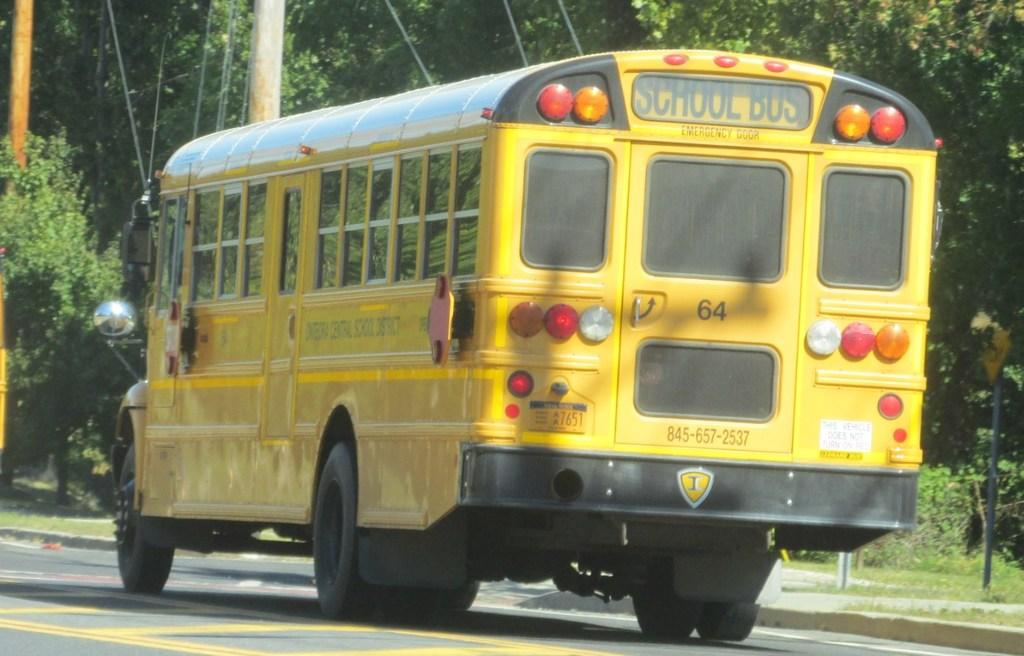What is the main subject of the picture? The main subject of the picture is a school bus. What colors are used for the school bus? The school bus is black and yellow in color. What can be seen in the background of the picture? Trees are visible in the picture. What other objects can be seen in the picture? There are poles in the picture. Can you tell me how many stamps are on the roof of the school bus in the image? There are no stamps visible on the roof of the school bus in the image. Who is the friend sitting next to the driver in the school bus? There is no friend sitting next to the driver in the image, as it only shows the exterior of the school bus. 